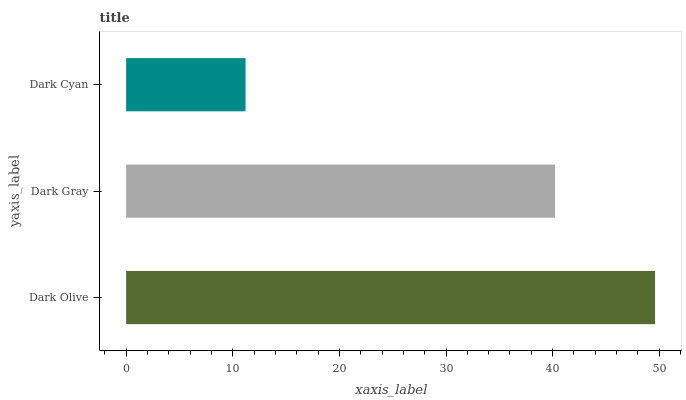Is Dark Cyan the minimum?
Answer yes or no. Yes. Is Dark Olive the maximum?
Answer yes or no. Yes. Is Dark Gray the minimum?
Answer yes or no. No. Is Dark Gray the maximum?
Answer yes or no. No. Is Dark Olive greater than Dark Gray?
Answer yes or no. Yes. Is Dark Gray less than Dark Olive?
Answer yes or no. Yes. Is Dark Gray greater than Dark Olive?
Answer yes or no. No. Is Dark Olive less than Dark Gray?
Answer yes or no. No. Is Dark Gray the high median?
Answer yes or no. Yes. Is Dark Gray the low median?
Answer yes or no. Yes. Is Dark Cyan the high median?
Answer yes or no. No. Is Dark Cyan the low median?
Answer yes or no. No. 